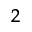<formula> <loc_0><loc_0><loc_500><loc_500>^ { 2 }</formula> 